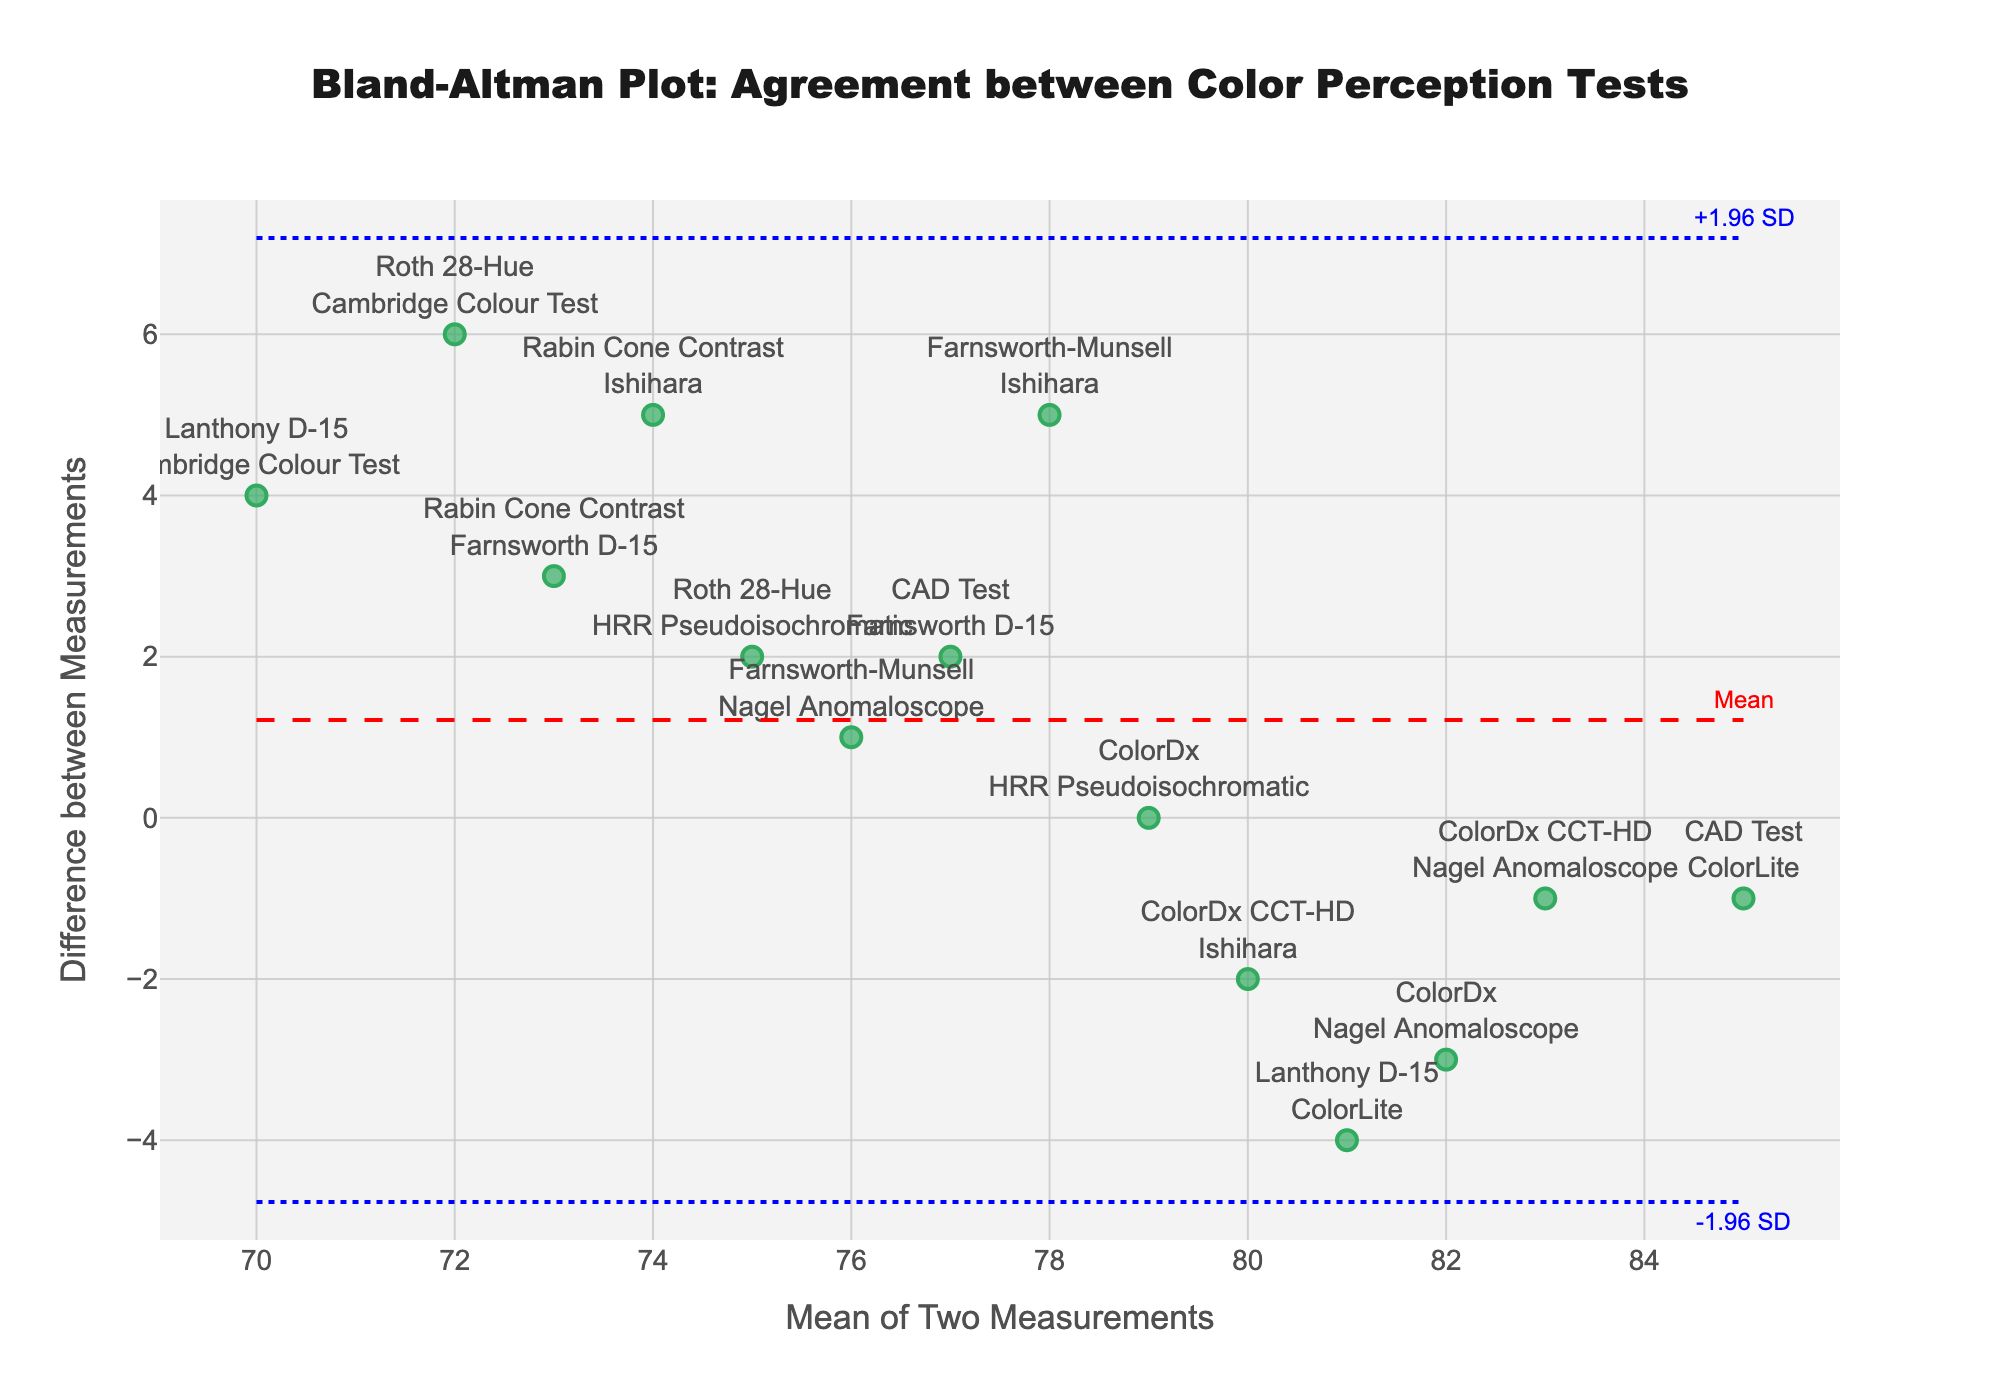What is the title of the figure? The title is usually displayed at the top of the figure, which in this case reads "Bland-Altman Plot: Agreement between Color Perception Tests"
Answer: Bland-Altman Plot: Agreement between Color Perception Tests How many data points are plotted in the figure? By counting the markers on the scatter plot, you can see there are 14 separate data points representing 14 different test comparisons.
Answer: 14 What are the values of the limits of agreement? The upper limit is calculated as the mean difference plus 1.96 times the standard deviation, and the lower limit as the mean difference minus 1.96 times the standard deviation. From the plot, the lines are drawn at these points and the text annotations "+1.96 SD" for the upper limit and "-1.96 SD" for the lower limit indicate their positions.
Answer: +1.96 SD, -1.96 SD Which comparison has the largest positive difference? Looking at the scatter plot, the comparison with the difference closest to the top edge of the plot has the largest positive difference. This is the comparison "Roth 28-Hue" vs "Cambridge Colour Test" with a difference value of 6.
Answer: Roth 28-Hue vs Cambridge Colour Test What is the central red dashed line in the plot? The central red dashed line represents the mean difference, which indicates the average bias between the two measurements being compared.
Answer: Mean difference How does the "Farnsworth-Munsell vs Ishihara" comparison differ from the "CAD Test vs ColorLite" comparison in terms of their difference values? Find the points labeled "Farnsworth-Munsell vs Ishihara" and "CAD Test vs ColorLite" on the plot. "Farnsworth-Munsell vs Ishihara" has a difference of 5, while "CAD Test vs ColorLite" has a difference of -1. Therefore, "Farnsworth-Munsell vs Ishihara" has a larger difference value by 6 units.
Answer: 6 units What is the mean difference and how is it visually represented in the plot? The mean difference is the central value of all differences, typically shown as a horizontal dashed line. From the plot, this line runs across the horizontal axis at the value where most points are evenly distributed above and below it.
Answer: Central red dashed line 